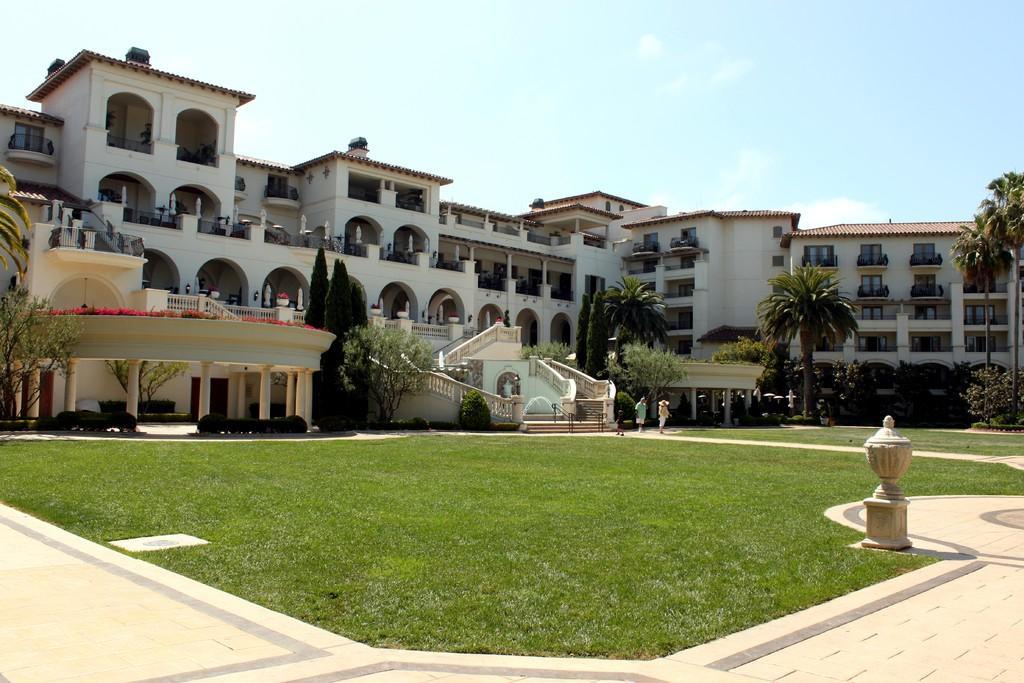Describe this image in one or two sentences. In this picture we can see an object and two people on a path, grass, pillars, trees, buildings with windows and in the background we can see the sky. 